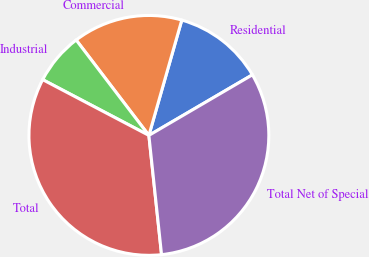Convert chart. <chart><loc_0><loc_0><loc_500><loc_500><pie_chart><fcel>Residential<fcel>Commercial<fcel>Industrial<fcel>Total<fcel>Total Net of Special<nl><fcel>12.15%<fcel>14.79%<fcel>6.94%<fcel>34.38%<fcel>31.74%<nl></chart> 